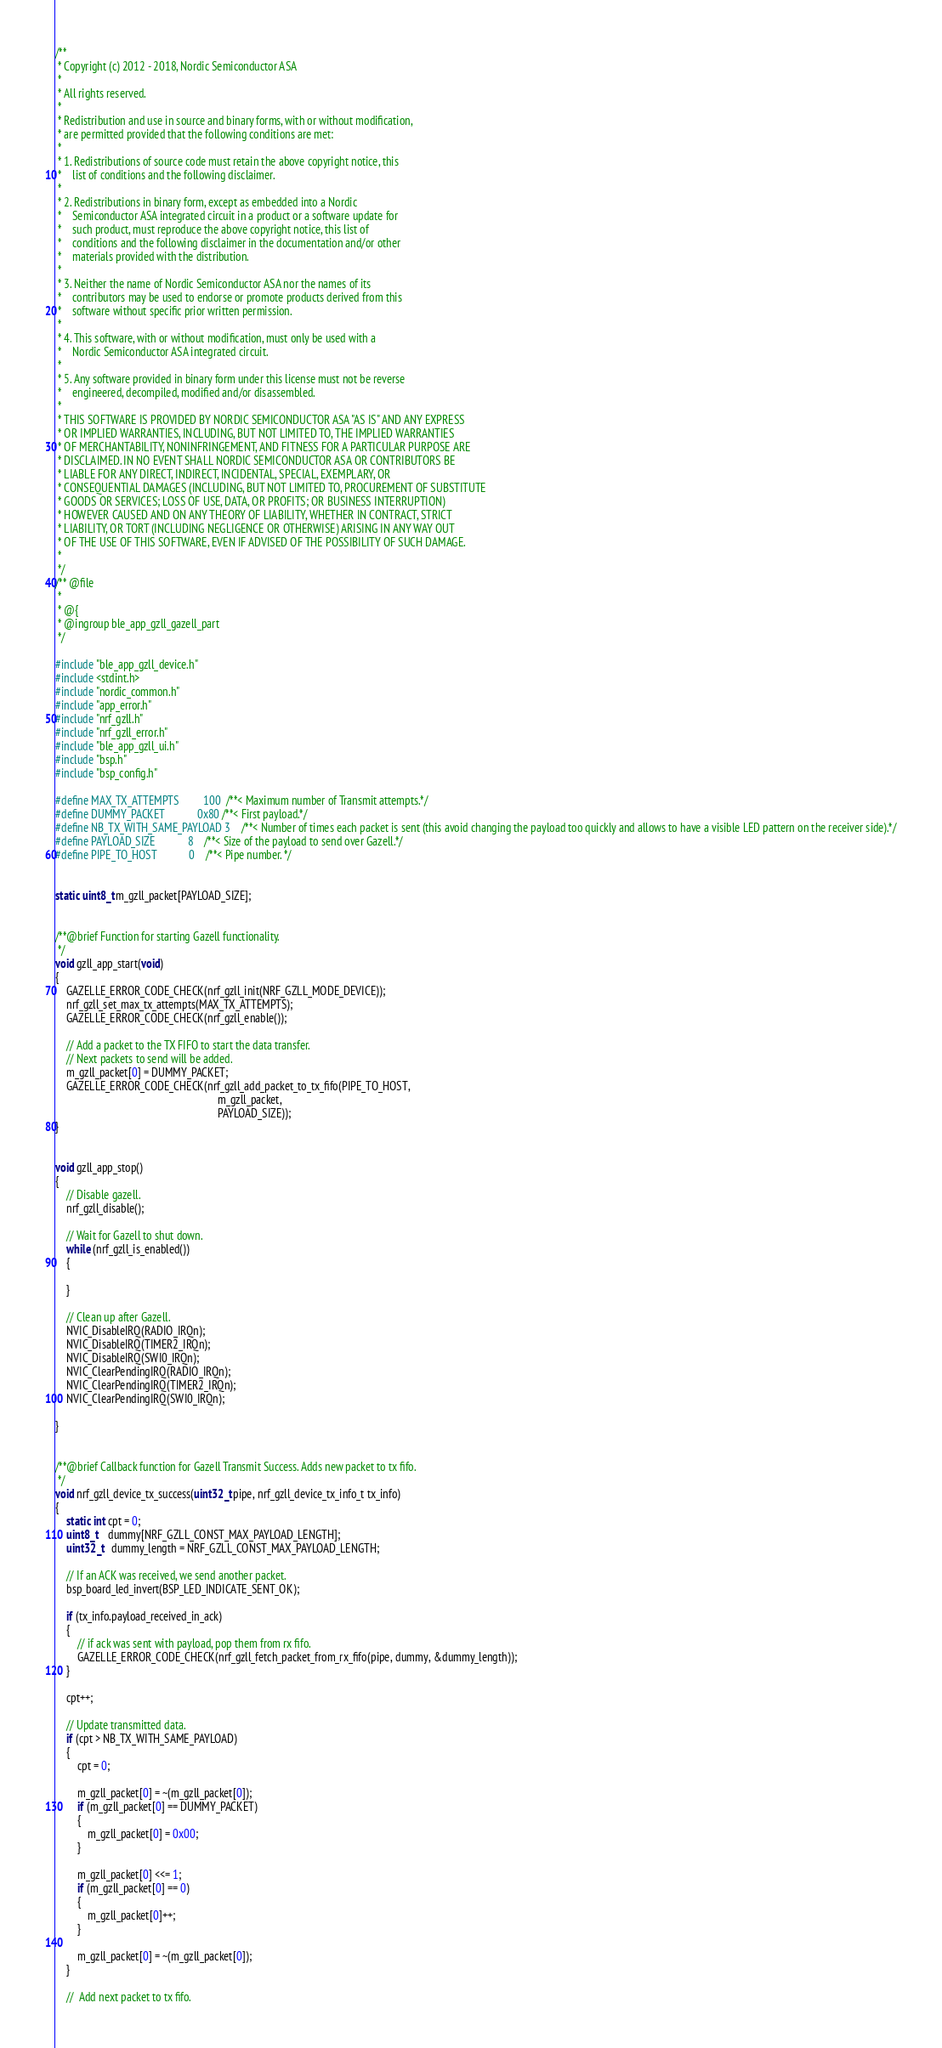Convert code to text. <code><loc_0><loc_0><loc_500><loc_500><_C_>/**
 * Copyright (c) 2012 - 2018, Nordic Semiconductor ASA
 *
 * All rights reserved.
 *
 * Redistribution and use in source and binary forms, with or without modification,
 * are permitted provided that the following conditions are met:
 *
 * 1. Redistributions of source code must retain the above copyright notice, this
 *    list of conditions and the following disclaimer.
 *
 * 2. Redistributions in binary form, except as embedded into a Nordic
 *    Semiconductor ASA integrated circuit in a product or a software update for
 *    such product, must reproduce the above copyright notice, this list of
 *    conditions and the following disclaimer in the documentation and/or other
 *    materials provided with the distribution.
 *
 * 3. Neither the name of Nordic Semiconductor ASA nor the names of its
 *    contributors may be used to endorse or promote products derived from this
 *    software without specific prior written permission.
 *
 * 4. This software, with or without modification, must only be used with a
 *    Nordic Semiconductor ASA integrated circuit.
 *
 * 5. Any software provided in binary form under this license must not be reverse
 *    engineered, decompiled, modified and/or disassembled.
 *
 * THIS SOFTWARE IS PROVIDED BY NORDIC SEMICONDUCTOR ASA "AS IS" AND ANY EXPRESS
 * OR IMPLIED WARRANTIES, INCLUDING, BUT NOT LIMITED TO, THE IMPLIED WARRANTIES
 * OF MERCHANTABILITY, NONINFRINGEMENT, AND FITNESS FOR A PARTICULAR PURPOSE ARE
 * DISCLAIMED. IN NO EVENT SHALL NORDIC SEMICONDUCTOR ASA OR CONTRIBUTORS BE
 * LIABLE FOR ANY DIRECT, INDIRECT, INCIDENTAL, SPECIAL, EXEMPLARY, OR
 * CONSEQUENTIAL DAMAGES (INCLUDING, BUT NOT LIMITED TO, PROCUREMENT OF SUBSTITUTE
 * GOODS OR SERVICES; LOSS OF USE, DATA, OR PROFITS; OR BUSINESS INTERRUPTION)
 * HOWEVER CAUSED AND ON ANY THEORY OF LIABILITY, WHETHER IN CONTRACT, STRICT
 * LIABILITY, OR TORT (INCLUDING NEGLIGENCE OR OTHERWISE) ARISING IN ANY WAY OUT
 * OF THE USE OF THIS SOFTWARE, EVEN IF ADVISED OF THE POSSIBILITY OF SUCH DAMAGE.
 *
 */
/** @file
 *
 * @{
 * @ingroup ble_app_gzll_gazell_part
 */

#include "ble_app_gzll_device.h"
#include <stdint.h>
#include "nordic_common.h"
#include "app_error.h"
#include "nrf_gzll.h"
#include "nrf_gzll_error.h"
#include "ble_app_gzll_ui.h"
#include "bsp.h"
#include "bsp_config.h"

#define MAX_TX_ATTEMPTS         100  /**< Maximum number of Transmit attempts.*/
#define DUMMY_PACKET            0x80 /**< First payload.*/
#define NB_TX_WITH_SAME_PAYLOAD 3    /**< Number of times each packet is sent (this avoid changing the payload too quickly and allows to have a visible LED pattern on the receiver side).*/
#define PAYLOAD_SIZE            8    /**< Size of the payload to send over Gazell.*/
#define PIPE_TO_HOST            0    /**< Pipe number. */


static uint8_t m_gzll_packet[PAYLOAD_SIZE];


/**@brief Function for starting Gazell functionality.
 */
void gzll_app_start(void)
{
    GAZELLE_ERROR_CODE_CHECK(nrf_gzll_init(NRF_GZLL_MODE_DEVICE));
    nrf_gzll_set_max_tx_attempts(MAX_TX_ATTEMPTS);
    GAZELLE_ERROR_CODE_CHECK(nrf_gzll_enable());

    // Add a packet to the TX FIFO to start the data transfer.
    // Next packets to send will be added.
    m_gzll_packet[0] = DUMMY_PACKET;
    GAZELLE_ERROR_CODE_CHECK(nrf_gzll_add_packet_to_tx_fifo(PIPE_TO_HOST,
                                                            m_gzll_packet,
                                                            PAYLOAD_SIZE));
}


void gzll_app_stop()
{
    // Disable gazell.
    nrf_gzll_disable();

    // Wait for Gazell to shut down.
    while (nrf_gzll_is_enabled())
    {

    }

    // Clean up after Gazell.
    NVIC_DisableIRQ(RADIO_IRQn);
    NVIC_DisableIRQ(TIMER2_IRQn);
    NVIC_DisableIRQ(SWI0_IRQn);
    NVIC_ClearPendingIRQ(RADIO_IRQn);
    NVIC_ClearPendingIRQ(TIMER2_IRQn);
    NVIC_ClearPendingIRQ(SWI0_IRQn);

}


/**@brief Callback function for Gazell Transmit Success. Adds new packet to tx fifo.
 */
void nrf_gzll_device_tx_success(uint32_t pipe, nrf_gzll_device_tx_info_t tx_info)
{
    static int cpt = 0;
    uint8_t    dummy[NRF_GZLL_CONST_MAX_PAYLOAD_LENGTH];
    uint32_t   dummy_length = NRF_GZLL_CONST_MAX_PAYLOAD_LENGTH;

    // If an ACK was received, we send another packet.
    bsp_board_led_invert(BSP_LED_INDICATE_SENT_OK);

    if (tx_info.payload_received_in_ack)
    {
        // if ack was sent with payload, pop them from rx fifo.
        GAZELLE_ERROR_CODE_CHECK(nrf_gzll_fetch_packet_from_rx_fifo(pipe, dummy, &dummy_length));
    }

    cpt++;

    // Update transmitted data.
    if (cpt > NB_TX_WITH_SAME_PAYLOAD)
    {
        cpt = 0;

        m_gzll_packet[0] = ~(m_gzll_packet[0]);
        if (m_gzll_packet[0] == DUMMY_PACKET)
        {
            m_gzll_packet[0] = 0x00;
        }

        m_gzll_packet[0] <<= 1;
        if (m_gzll_packet[0] == 0)
        {
            m_gzll_packet[0]++;
        }

        m_gzll_packet[0] = ~(m_gzll_packet[0]);
    }

    //  Add next packet to tx fifo.</code> 